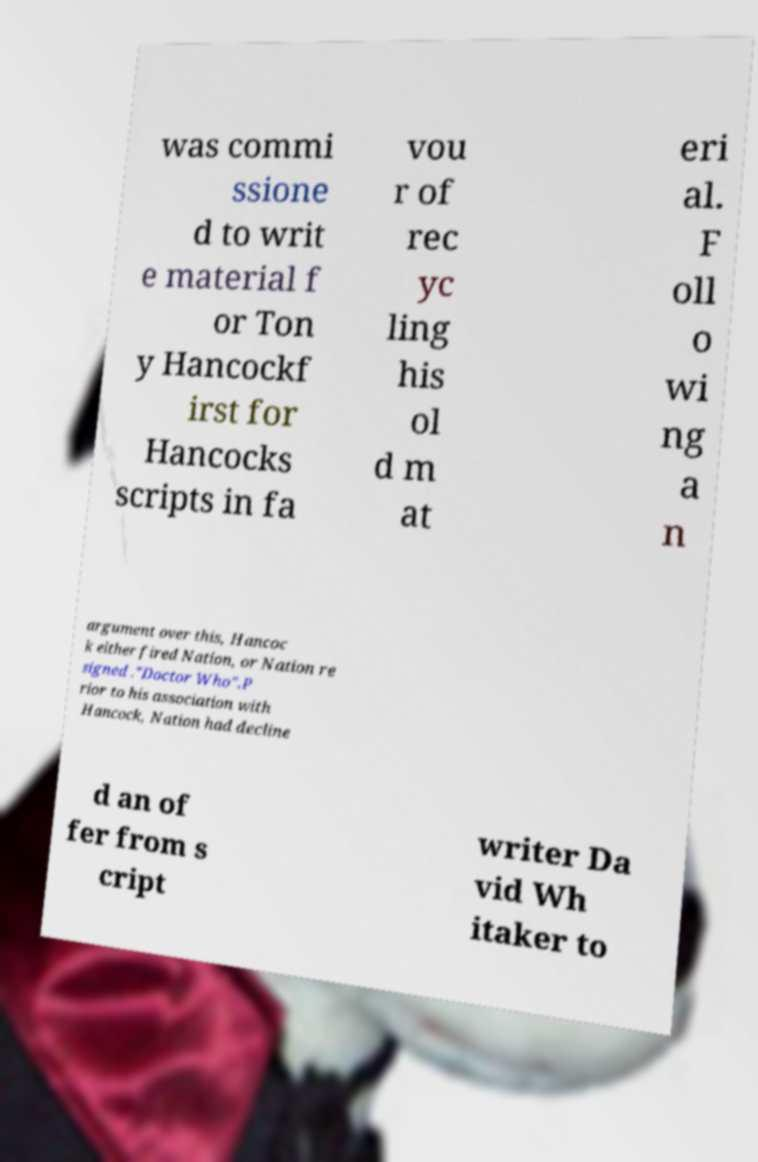Please read and relay the text visible in this image. What does it say? was commi ssione d to writ e material f or Ton y Hancockf irst for Hancocks scripts in fa vou r of rec yc ling his ol d m at eri al. F oll o wi ng a n argument over this, Hancoc k either fired Nation, or Nation re signed ."Doctor Who".P rior to his association with Hancock, Nation had decline d an of fer from s cript writer Da vid Wh itaker to 